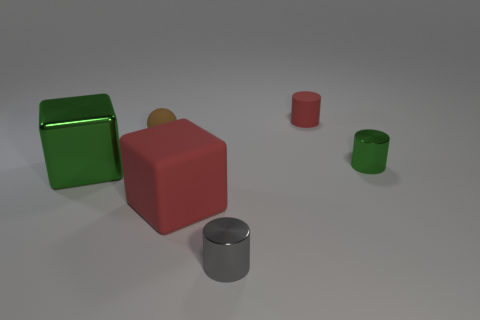Subtract all small matte cylinders. How many cylinders are left? 2 Add 3 tiny gray shiny objects. How many objects exist? 9 Subtract 2 cylinders. How many cylinders are left? 1 Subtract all green blocks. How many blocks are left? 1 Subtract all blocks. How many objects are left? 4 Subtract all cyan blocks. Subtract all cyan cylinders. How many blocks are left? 2 Subtract all purple cylinders. How many gray cubes are left? 0 Subtract all yellow cubes. Subtract all green metallic blocks. How many objects are left? 5 Add 1 red rubber cylinders. How many red rubber cylinders are left? 2 Add 2 big purple things. How many big purple things exist? 2 